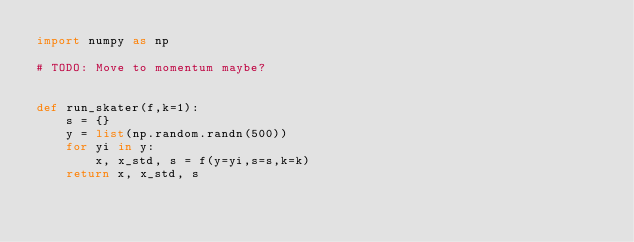Convert code to text. <code><loc_0><loc_0><loc_500><loc_500><_Python_>import numpy as np

# TODO: Move to momentum maybe?


def run_skater(f,k=1):
    s = {}
    y = list(np.random.randn(500))
    for yi in y:
        x, x_std, s = f(y=yi,s=s,k=k)
    return x, x_std, s
</code> 